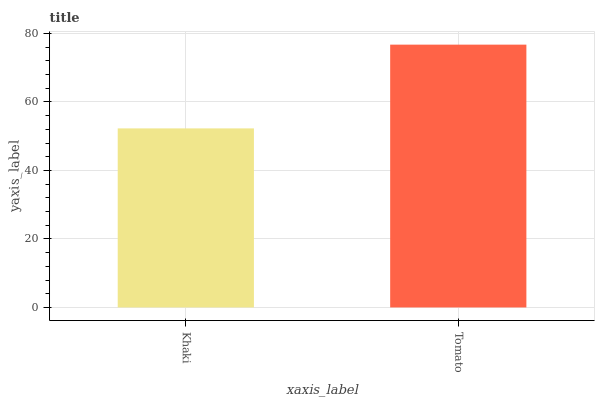Is Khaki the minimum?
Answer yes or no. Yes. Is Tomato the maximum?
Answer yes or no. Yes. Is Tomato the minimum?
Answer yes or no. No. Is Tomato greater than Khaki?
Answer yes or no. Yes. Is Khaki less than Tomato?
Answer yes or no. Yes. Is Khaki greater than Tomato?
Answer yes or no. No. Is Tomato less than Khaki?
Answer yes or no. No. Is Tomato the high median?
Answer yes or no. Yes. Is Khaki the low median?
Answer yes or no. Yes. Is Khaki the high median?
Answer yes or no. No. Is Tomato the low median?
Answer yes or no. No. 